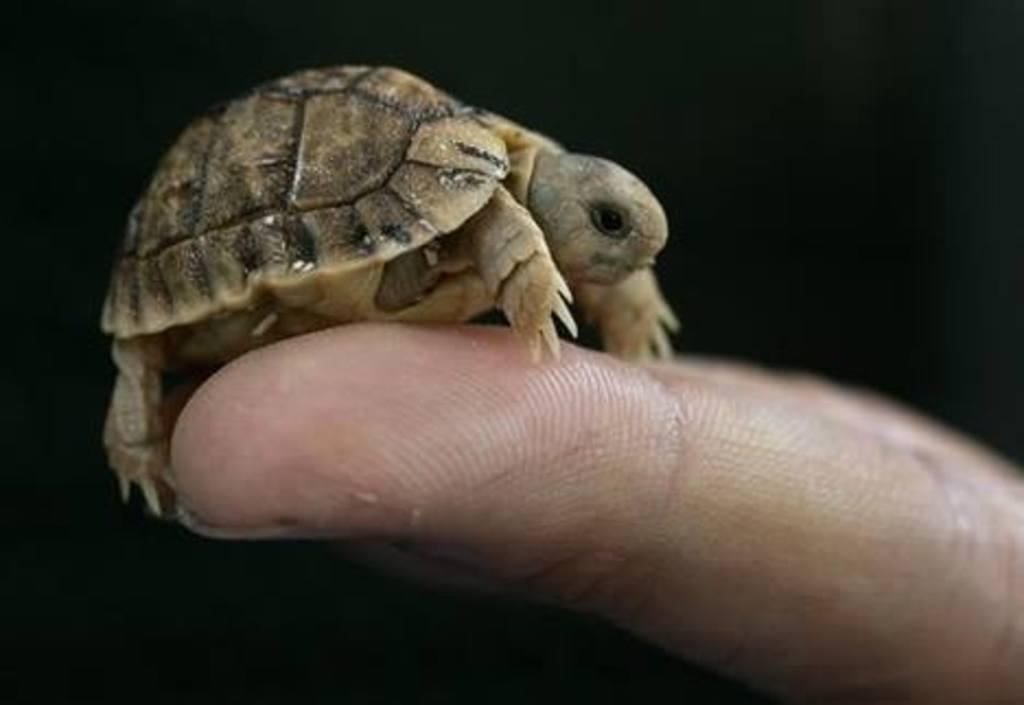What type of animal is in the image? There is a small turtle in the image. Who is holding the turtle? The turtle is being held by a human. What color is the background of the image? The background of the image is black. What type of lumber is being used to guide the turtle in the image? There is no lumber or guiding object present in the image; it only features a small turtle being held by a human with a black background. 